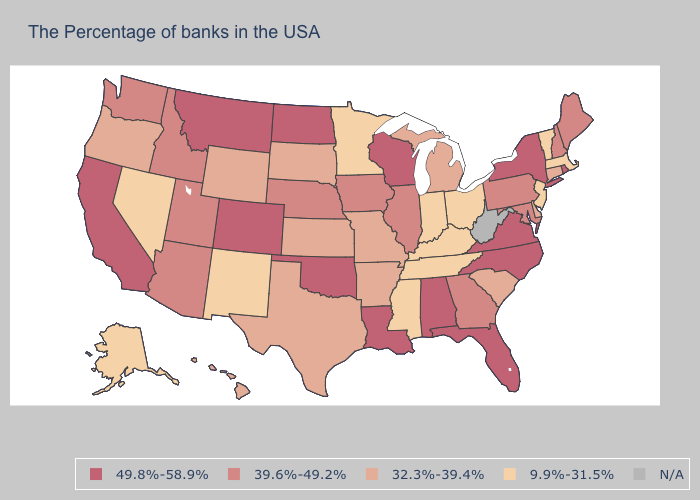Which states have the lowest value in the USA?
Answer briefly. Massachusetts, Vermont, New Jersey, Ohio, Kentucky, Indiana, Tennessee, Mississippi, Minnesota, New Mexico, Nevada, Alaska. Name the states that have a value in the range 49.8%-58.9%?
Concise answer only. Rhode Island, New York, Virginia, North Carolina, Florida, Alabama, Wisconsin, Louisiana, Oklahoma, North Dakota, Colorado, Montana, California. Is the legend a continuous bar?
Keep it brief. No. Name the states that have a value in the range N/A?
Be succinct. West Virginia. Among the states that border Oklahoma , does New Mexico have the lowest value?
Give a very brief answer. Yes. Name the states that have a value in the range 49.8%-58.9%?
Write a very short answer. Rhode Island, New York, Virginia, North Carolina, Florida, Alabama, Wisconsin, Louisiana, Oklahoma, North Dakota, Colorado, Montana, California. Name the states that have a value in the range 32.3%-39.4%?
Write a very short answer. Connecticut, Delaware, South Carolina, Michigan, Missouri, Arkansas, Kansas, Texas, South Dakota, Wyoming, Oregon, Hawaii. Name the states that have a value in the range 49.8%-58.9%?
Keep it brief. Rhode Island, New York, Virginia, North Carolina, Florida, Alabama, Wisconsin, Louisiana, Oklahoma, North Dakota, Colorado, Montana, California. What is the lowest value in states that border Idaho?
Write a very short answer. 9.9%-31.5%. What is the value of North Dakota?
Be succinct. 49.8%-58.9%. Name the states that have a value in the range N/A?
Concise answer only. West Virginia. Name the states that have a value in the range 9.9%-31.5%?
Quick response, please. Massachusetts, Vermont, New Jersey, Ohio, Kentucky, Indiana, Tennessee, Mississippi, Minnesota, New Mexico, Nevada, Alaska. Name the states that have a value in the range 32.3%-39.4%?
Keep it brief. Connecticut, Delaware, South Carolina, Michigan, Missouri, Arkansas, Kansas, Texas, South Dakota, Wyoming, Oregon, Hawaii. Name the states that have a value in the range 9.9%-31.5%?
Give a very brief answer. Massachusetts, Vermont, New Jersey, Ohio, Kentucky, Indiana, Tennessee, Mississippi, Minnesota, New Mexico, Nevada, Alaska. Among the states that border New Mexico , does Texas have the lowest value?
Write a very short answer. Yes. 